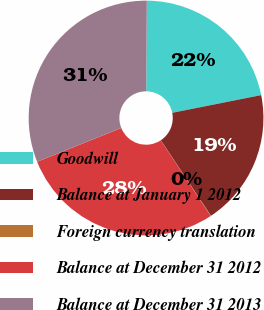Convert chart to OTSL. <chart><loc_0><loc_0><loc_500><loc_500><pie_chart><fcel>Goodwill<fcel>Balance at January 1 2012<fcel>Foreign currency translation<fcel>Balance at December 31 2012<fcel>Balance at December 31 2013<nl><fcel>21.77%<fcel>18.8%<fcel>0.04%<fcel>28.21%<fcel>31.18%<nl></chart> 